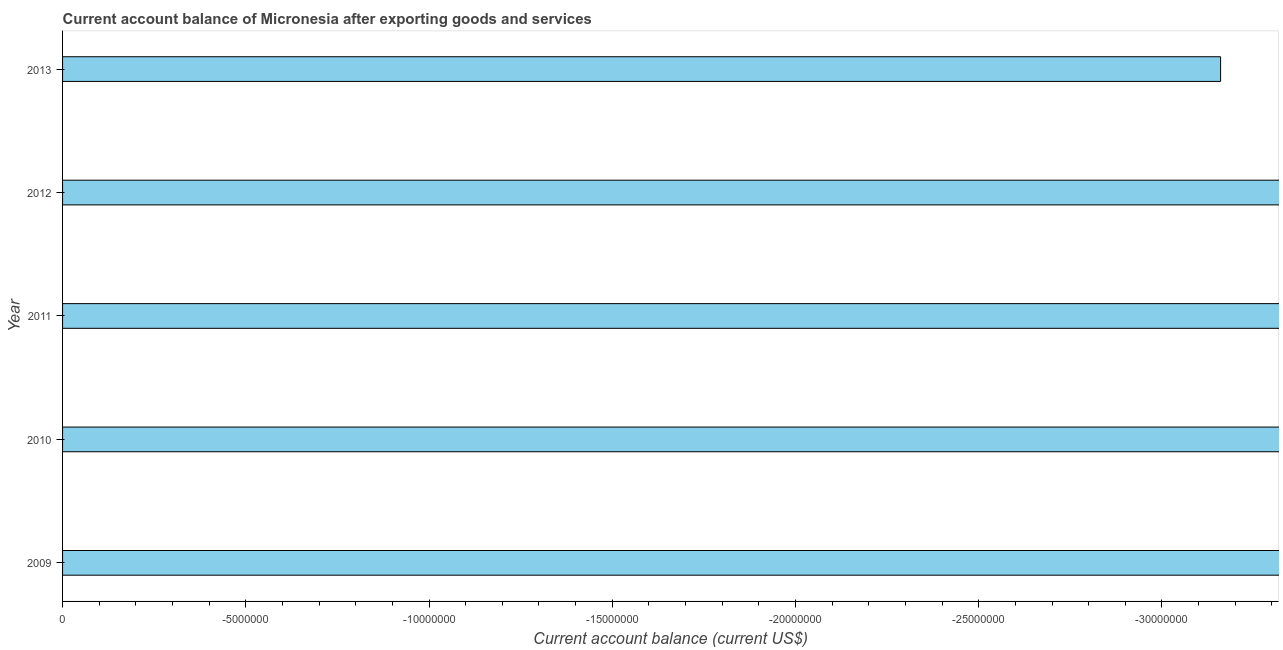Does the graph contain any zero values?
Your response must be concise. Yes. Does the graph contain grids?
Offer a terse response. No. What is the title of the graph?
Your response must be concise. Current account balance of Micronesia after exporting goods and services. What is the label or title of the X-axis?
Keep it short and to the point. Current account balance (current US$). What is the label or title of the Y-axis?
Offer a terse response. Year. Across all years, what is the minimum current account balance?
Provide a succinct answer. 0. In how many years, is the current account balance greater than -30000000 US$?
Ensure brevity in your answer.  0. In how many years, is the current account balance greater than the average current account balance taken over all years?
Your answer should be very brief. 0. How many bars are there?
Provide a succinct answer. 0. How many years are there in the graph?
Keep it short and to the point. 5. What is the difference between two consecutive major ticks on the X-axis?
Offer a terse response. 5.00e+06. What is the Current account balance (current US$) in 2009?
Your answer should be very brief. 0. What is the Current account balance (current US$) in 2011?
Your answer should be compact. 0. What is the Current account balance (current US$) of 2013?
Ensure brevity in your answer.  0. 